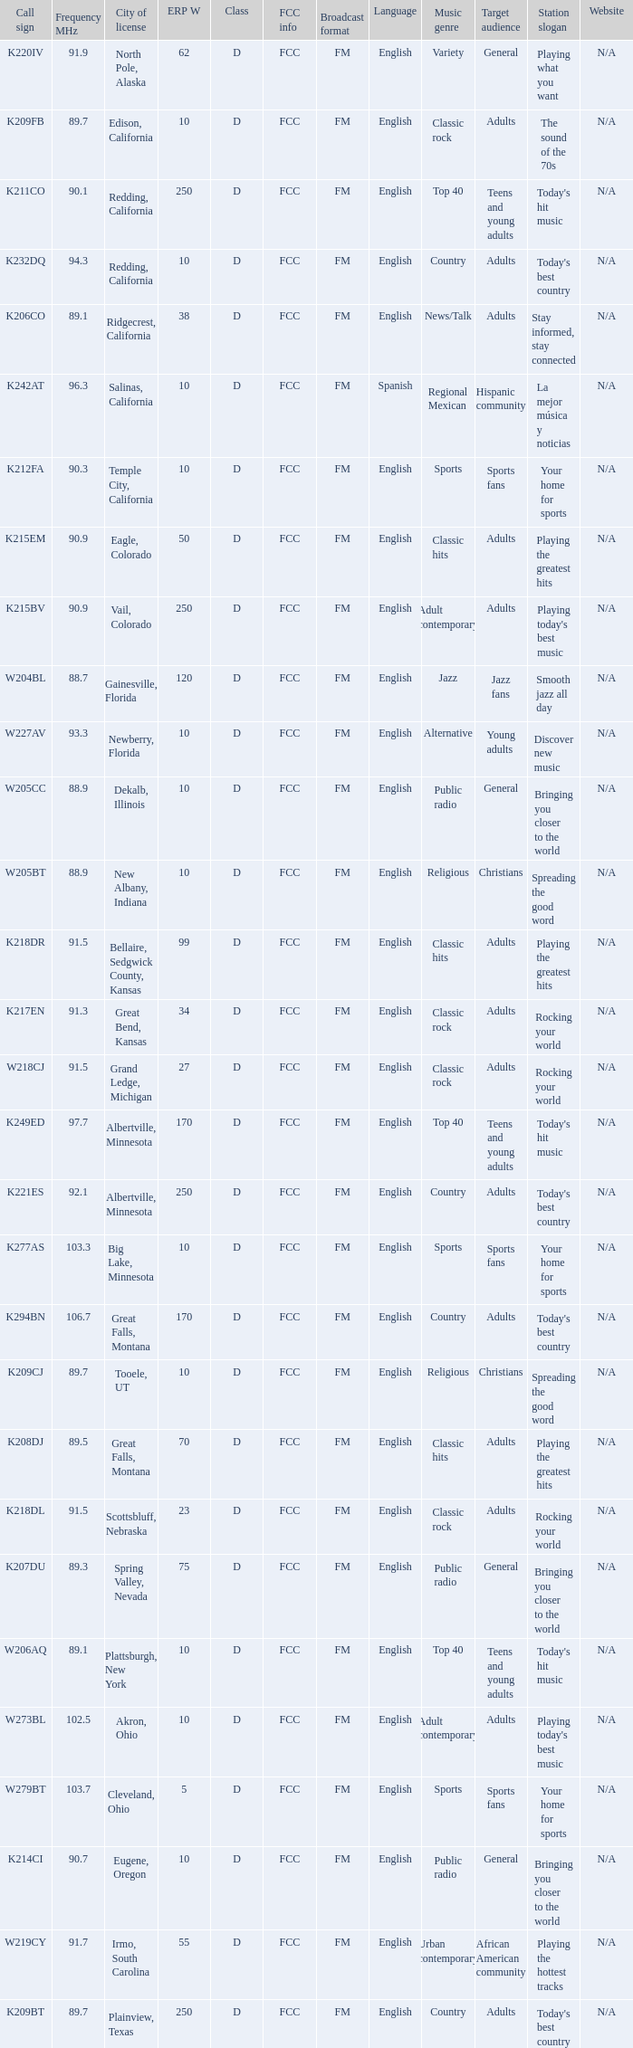What is the class of the translator with 10 ERP W and a call sign of w273bl? D. 